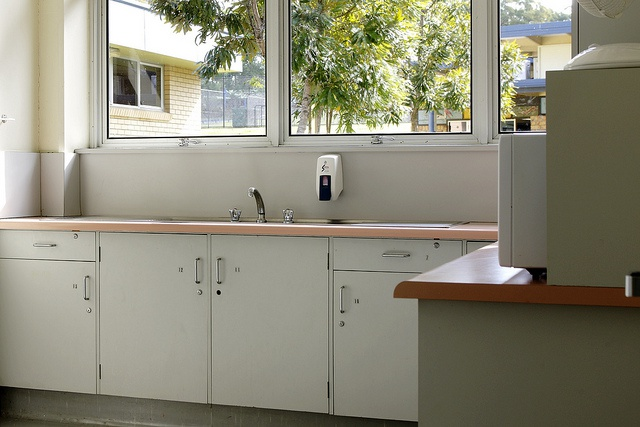Describe the objects in this image and their specific colors. I can see microwave in lightgray, gray, darkgreen, black, and lavender tones and sink in lightgray, gray, and darkgray tones in this image. 